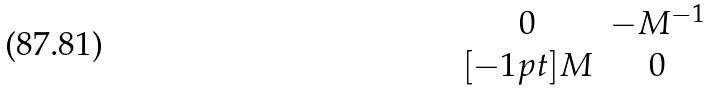<formula> <loc_0><loc_0><loc_500><loc_500>\begin{matrix} 0 & - M ^ { - 1 } \\ [ - 1 p t ] M & 0 \end{matrix}</formula> 